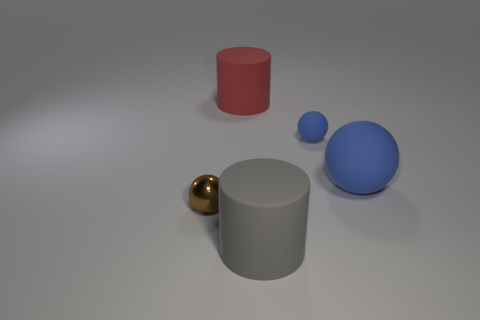Subtract all yellow cylinders. How many blue balls are left? 2 Subtract all big rubber spheres. How many spheres are left? 2 Add 5 tiny yellow cylinders. How many objects exist? 10 Subtract all spheres. How many objects are left? 2 Subtract all yellow balls. Subtract all green cylinders. How many balls are left? 3 Add 4 small blue spheres. How many small blue spheres exist? 5 Subtract 0 green spheres. How many objects are left? 5 Subtract all metallic spheres. Subtract all brown metallic balls. How many objects are left? 3 Add 2 big rubber objects. How many big rubber objects are left? 5 